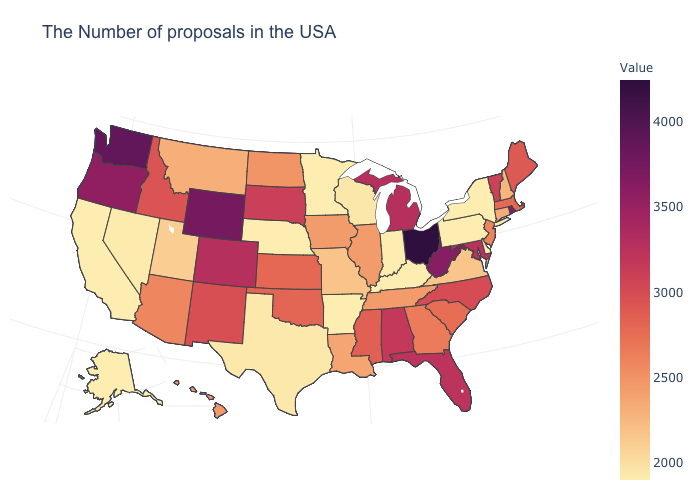Among the states that border Arizona , which have the highest value?
Answer briefly. Colorado. Does Alabama have a lower value than Missouri?
Concise answer only. No. Which states hav the highest value in the West?
Short answer required. Washington. Does Idaho have the lowest value in the USA?
Short answer required. No. Which states have the lowest value in the USA?
Quick response, please. New York, Delaware, Pennsylvania, Kentucky, Indiana, Arkansas, Minnesota, Nebraska, California, Alaska. 